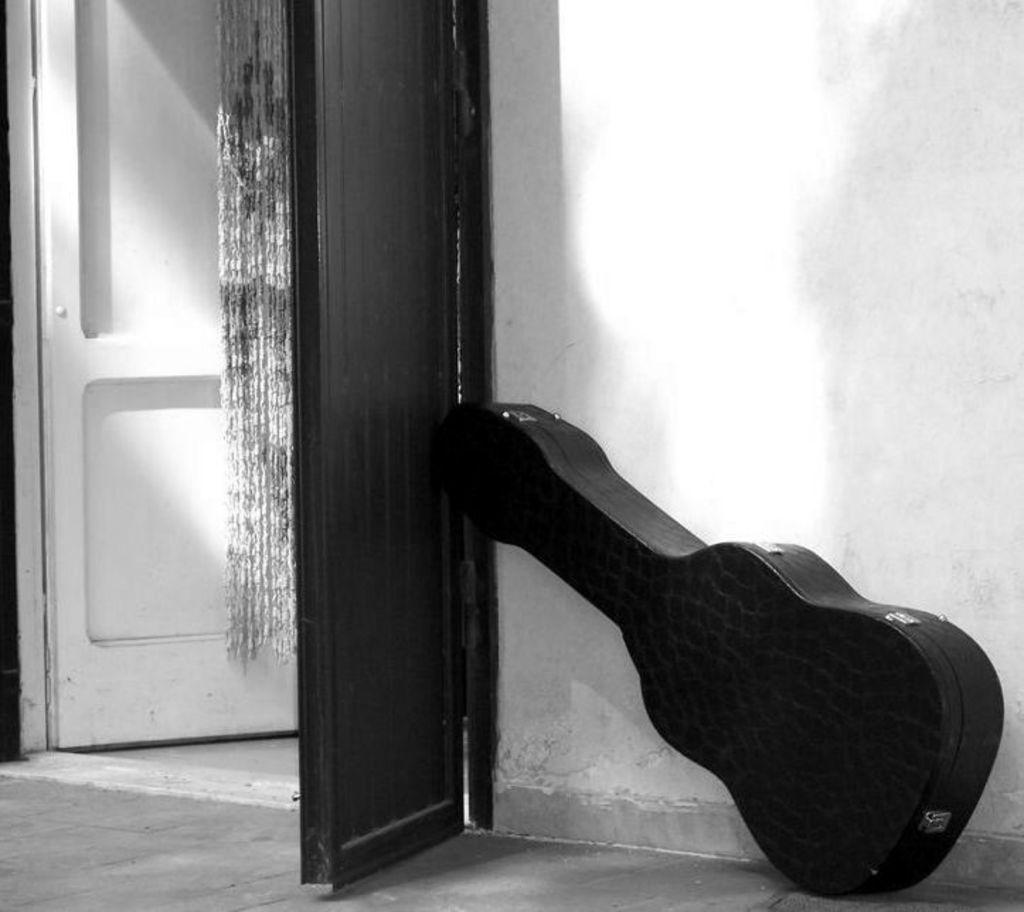What is the color scheme of the image? The image is black and white. What type of architectural feature can be seen in the image? There are doors in the image. What object related to music is present in the image? There is a guitar box in the image. What type of structure can be seen in the image? There is a wall in the image. What is visible beneath the objects and structures in the image? The surface (likely the floor or ground) is visible in the image. Where is the nearest downtown area in relation to the image? The provided facts do not mention any downtown area, so it cannot be determined from the image. 